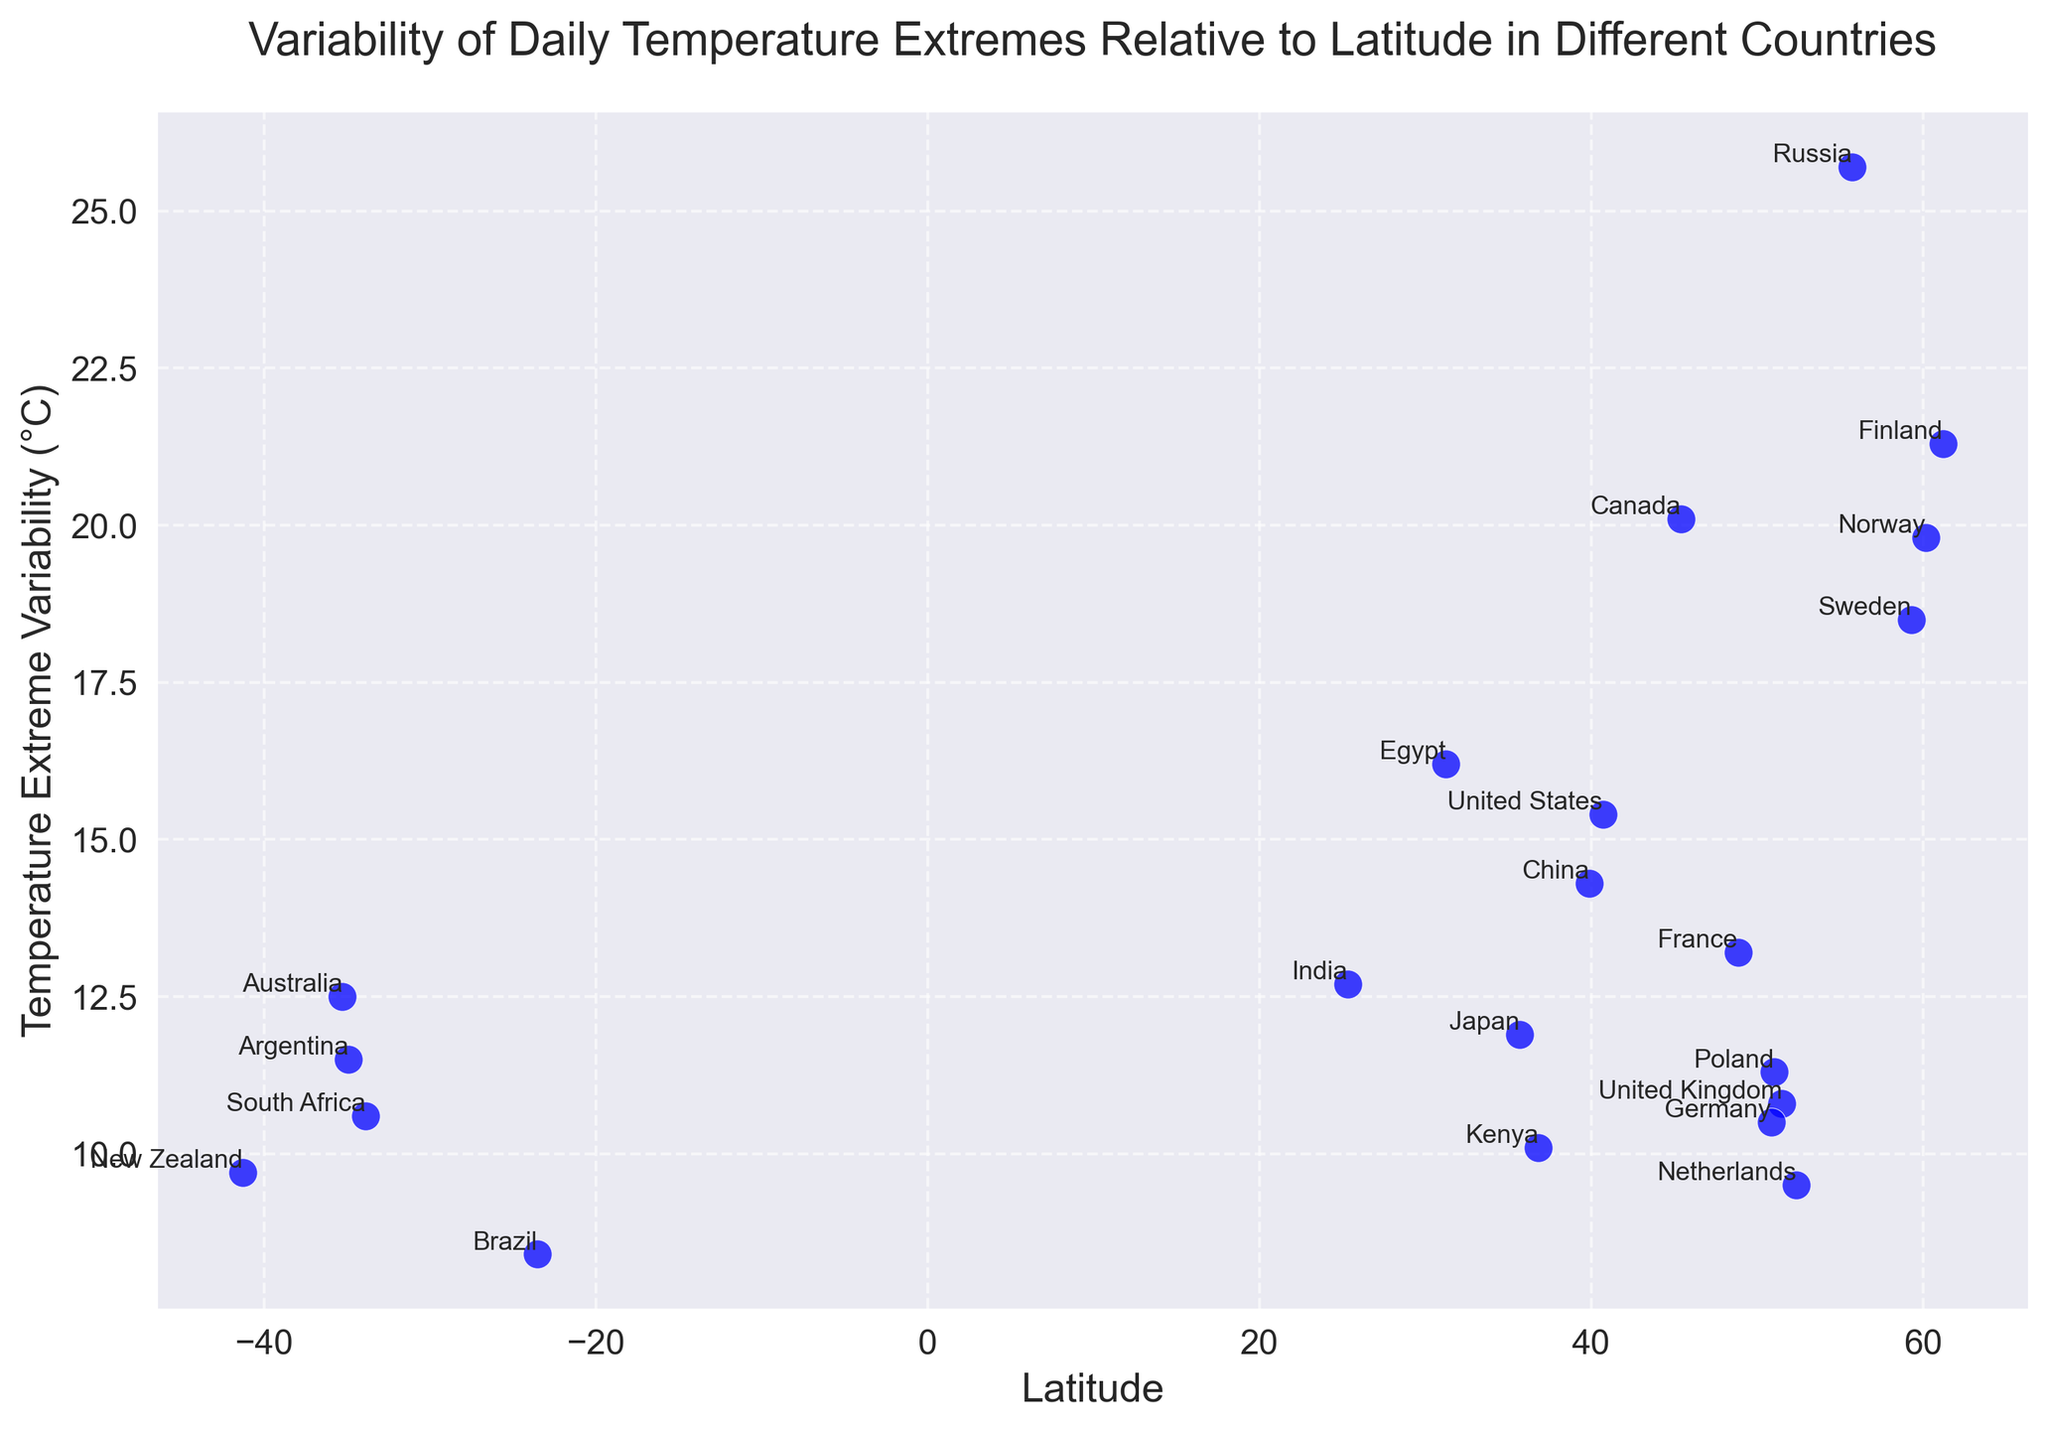Which country has the highest variability in daily temperature extremes? By looking at the highest point on the vertical axis, we can see that Russia has the highest variability in daily temperature extremes at 25.7°C.
Answer: Russia Which country falls closest to a latitude of 0 (Equator) and what is its temperature extreme variability? The country closest to the Equator would have a latitude near 0. Brazil, which has a latitude of -23.55, is the closest to the Equator and has a temperature extreme variability of 8.4°C.
Answer: Brazil, 8.4°C Compare the temperature extreme variability between Canada and the United Kingdom. Which one has a higher variability and by how much? Canada has a temperature extreme variability of 20.1°C, while the United Kingdom has 10.8°C. The difference is 20.1 - 10.8 = 9.3°C.
Answer: Canada, 9.3°C Is there a general trend between latitude and temperature extreme variability? Observing the scatter plot shows that as the latitude increases, the temperature extreme variability also tends to increase. Countries with higher latitudes tend to have greater variability in temperature extremes.
Answer: Yes, increasing latitude tends to increase variability Which countries have a temperature extreme variability below 10°C? By examining the y-axis for points below 10°C, we find Brazil (8.4°C), Netherlands (9.5°C), and New Zealand (9.7°C).
Answer: Brazil, Netherlands, New Zealand What is the average temperature extreme variability of countries with latitudes greater than 50°? Only consider countries with a latitude greater than 50: Canada (20.1°C), Finland (21.3°C), United Kingdom (10.8°C), Russia (25.7°C), Sweden (18.5°C), Norway (19.8°C), Germany (10.5°C), and Poland (11.3°C). Sum these values: 20.1 + 21.3 + 10.8 + 25.7 + 18.5 + 19.8 + 10.5 + 11.3 = 138.0. Divide by the number of countries: 138.0 / 8 = 17.25°C.
Answer: 17.25°C Which country at latitude lower than 0 has the highest temperature extreme variability and what is the value? Looking at the latitudes less than 0, we see Australia (-35.28, 12.5°C), South Africa (-33.87, 10.6°C), Brazil (-23.55, 8.4°C), Argentina (-34.92, 11.5°C), and New Zealand (-41.29, 9.7°C). Australia has the highest variability at 12.5°C.
Answer: Australia, 12.5°C In terms of continents, which continent has the widest range in temperature extreme variability among its countries? By evaluating the given data, Europe has countries with a wide range: Finland (21.3°C), France (13.2°C), United Kingdom (10.8°C), Russia (25.7°C), Netherlands (9.5°C), Sweden (18.5°C), Germany (10.5°C), Poland (11.3°C). The difference between the highest and lowest variabilities is 25.7 - 9.5 = 16.2°C.
Answer: Europe Which is the country with the lowest temperature extreme variability and how low is it? The country with the lowest temperature extreme variability is Brazil, with a value of 8.4°C.
Answer: Brazil, 8.4°C Comparing China and Egypt, which one has a higher latitude and do they have a similar temperature extreme variability? China has a latitude of 39.90, while Egypt has a latitude of 31.23. China has a higher latitude. The temperature extreme variability for China is 14.3°C and for Egypt is 16.2°C, which are relatively close but not exactly the same.
Answer: China has a higher latitude; their variabilities are close but not the same 